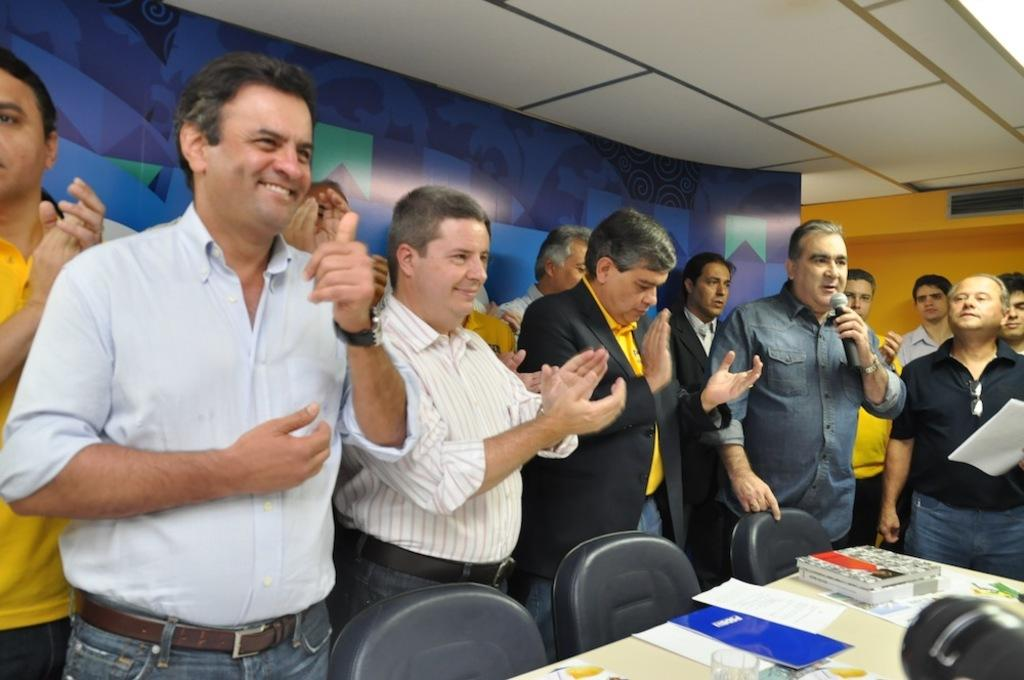How many people are present in the image? There are many people in the image. What are some of the people doing in the image? Some people are standing, and some people are clapping. Can you describe the person on the right side of the image? There is a person holding a paper on the right side of the image. What type of dinosaurs can be seen flying in the image? There are no dinosaurs present in the image, let alone flying ones. 